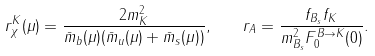Convert formula to latex. <formula><loc_0><loc_0><loc_500><loc_500>r ^ { K } _ { \chi } ( \mu ) = \frac { 2 m ^ { 2 } _ { K } } { \bar { m } _ { b } ( \mu ) ( \bar { m } _ { u } ( \mu ) + \bar { m } _ { s } ( \mu ) ) } , \quad r _ { A } = \frac { f _ { B _ { s } } f _ { K } } { m ^ { 2 } _ { B _ { s } } F ^ { B \to K } _ { 0 } ( 0 ) } .</formula> 